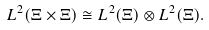<formula> <loc_0><loc_0><loc_500><loc_500>L ^ { 2 } ( \Xi \times \Xi ) \cong L ^ { 2 } ( \Xi ) \otimes L ^ { 2 } ( \Xi ) .</formula> 